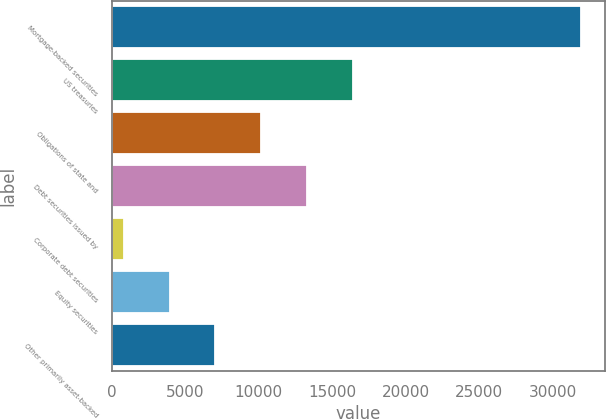Convert chart to OTSL. <chart><loc_0><loc_0><loc_500><loc_500><bar_chart><fcel>Mortgage-backed securities<fcel>US treasuries<fcel>Obligations of state and<fcel>Debt securities issued by<fcel>Corporate debt securities<fcel>Equity securities<fcel>Other primarily asset-backed<nl><fcel>31932<fcel>16382.5<fcel>10162.7<fcel>13272.6<fcel>833<fcel>3942.9<fcel>7052.8<nl></chart> 